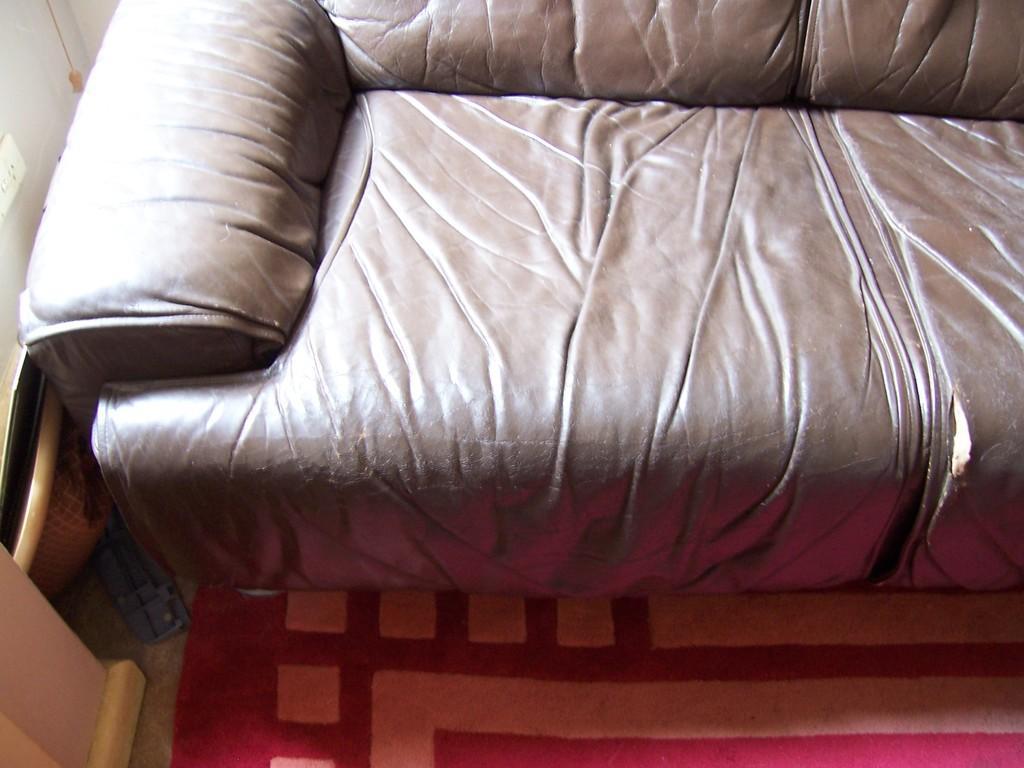How would you summarize this image in a sentence or two? There is a sofa and carpet on the floor. On the left there is a switch board,basket. 